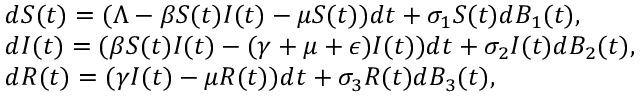<formula> <loc_0><loc_0><loc_500><loc_500>\begin{array} { r l } & { { d S ( t ) } = ( \Lambda - \beta S ( t ) I ( t ) - \mu S ( t ) ) d t + \sigma _ { 1 } S ( t ) d B _ { 1 } ( t ) , } \\ & { { d I ( t ) } = ( \beta S ( t ) I ( t ) - ( \gamma + \mu + \epsilon ) I ( t ) ) d t + \sigma _ { 2 } I ( t ) d B _ { 2 } ( t ) , } \\ & { { d R ( t ) } = ( \gamma I ( t ) - \mu R ( t ) ) d t + \sigma _ { 3 } R ( t ) d B _ { 3 } ( t ) , } \end{array}</formula> 